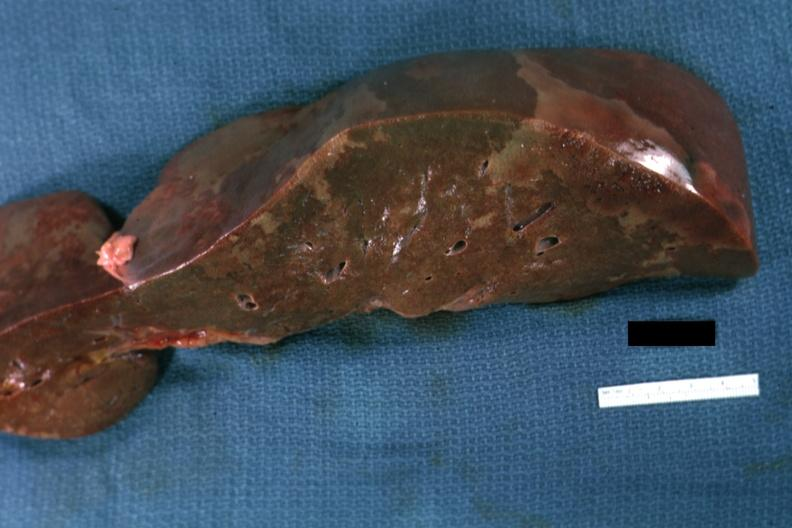s hepatobiliary present?
Answer the question using a single word or phrase. Yes 